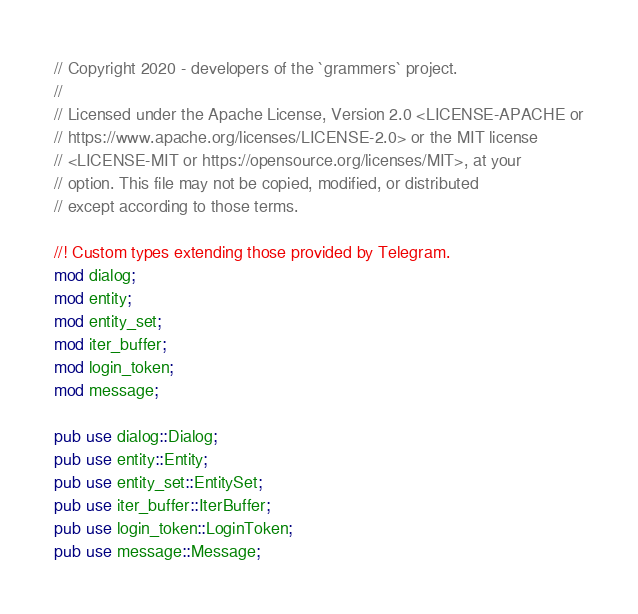<code> <loc_0><loc_0><loc_500><loc_500><_Rust_>// Copyright 2020 - developers of the `grammers` project.
//
// Licensed under the Apache License, Version 2.0 <LICENSE-APACHE or
// https://www.apache.org/licenses/LICENSE-2.0> or the MIT license
// <LICENSE-MIT or https://opensource.org/licenses/MIT>, at your
// option. This file may not be copied, modified, or distributed
// except according to those terms.

//! Custom types extending those provided by Telegram.
mod dialog;
mod entity;
mod entity_set;
mod iter_buffer;
mod login_token;
mod message;

pub use dialog::Dialog;
pub use entity::Entity;
pub use entity_set::EntitySet;
pub use iter_buffer::IterBuffer;
pub use login_token::LoginToken;
pub use message::Message;
</code> 